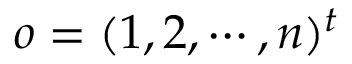Convert formula to latex. <formula><loc_0><loc_0><loc_500><loc_500>o = ( 1 , 2 , \cdots , n ) ^ { t }</formula> 